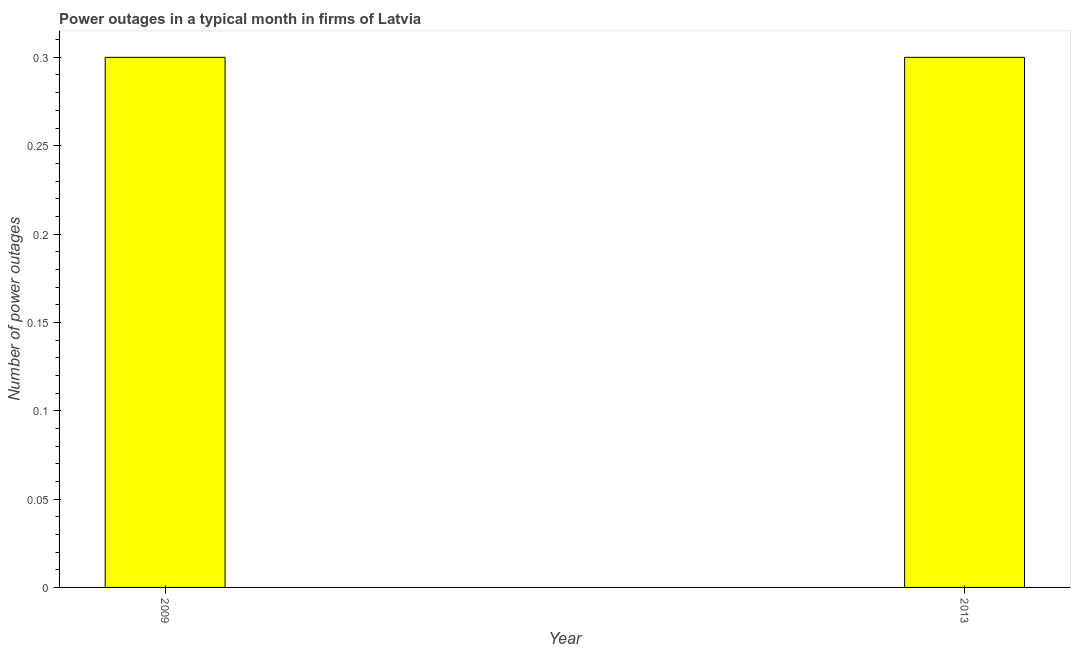Does the graph contain any zero values?
Keep it short and to the point. No. What is the title of the graph?
Offer a terse response. Power outages in a typical month in firms of Latvia. What is the label or title of the Y-axis?
Provide a succinct answer. Number of power outages. In which year was the number of power outages maximum?
Make the answer very short. 2009. What is the difference between the number of power outages in 2009 and 2013?
Keep it short and to the point. 0. What is the average number of power outages per year?
Provide a succinct answer. 0.3. What is the median number of power outages?
Your answer should be compact. 0.3. Do a majority of the years between 2009 and 2013 (inclusive) have number of power outages greater than 0.09 ?
Offer a terse response. Yes. How many bars are there?
Your answer should be compact. 2. What is the Number of power outages of 2009?
Offer a terse response. 0.3. What is the Number of power outages of 2013?
Your answer should be very brief. 0.3. What is the difference between the Number of power outages in 2009 and 2013?
Ensure brevity in your answer.  0. 